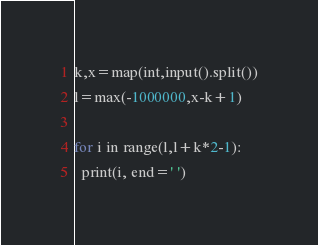<code> <loc_0><loc_0><loc_500><loc_500><_Python_>k,x=map(int,input().split())
l=max(-1000000,x-k+1)

for i in range(l,l+k*2-1):
  print(i, end=' ')</code> 